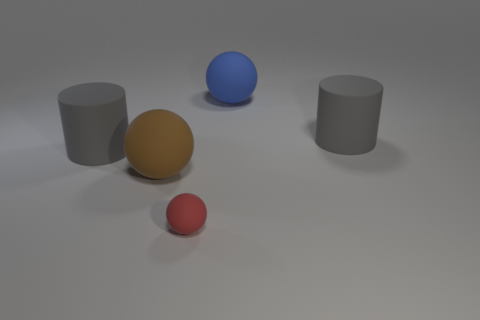Add 2 big blue blocks. How many objects exist? 7 Subtract all spheres. How many objects are left? 2 Subtract all tiny red things. Subtract all small blue shiny spheres. How many objects are left? 4 Add 1 big brown rubber objects. How many big brown rubber objects are left? 2 Add 3 rubber balls. How many rubber balls exist? 6 Subtract 0 cyan cylinders. How many objects are left? 5 